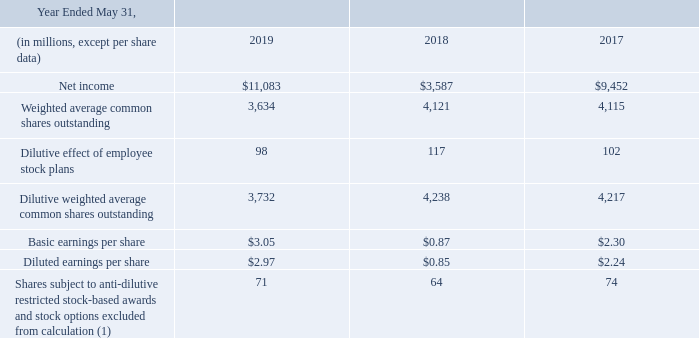Basic earnings per share is computed by dividing net income for the period by the weighted-average number of common shares outstanding during the period. Diluted earnings per share is computed by dividing net income for the period by the weighted-average number of common shares outstanding during the period, plus the dilutive effect of outstanding restricted stock-based awards, stock options, and shares issuable under the employee stock purchase plan using the treasury stock method. The following table sets forth the computation of basic and diluted earnings per share:
(1) These weighted shares relate to anti-dilutive restricted stock-based awards and stock options as calculated using the treasury stock method and contingently issuable shares under PSO and PSU agreements. Such shares could be dilutive in the future. See Note 13 for information regarding the exercise prices of our outstanding, unexercised stock options.
How is basic earnings per share calculated? Basic earnings per share is computed by dividing net income for the period by the weighted-average number of common shares outstanding during the period. Does the table show the calculations for basic or diluted earnings per share, or both? The following table sets forth the computation of basic and diluted earnings per share. Which note should be referred to for information regarding the exercise prices of the company's outstanding, unexercised stock options? See note 13 for information regarding the exercise prices of our outstanding, unexercised stock options. By how much did net income change from 2018 to 2019?
Answer scale should be: million. 11,083-3,587 
Answer: 7496. In 2019, how much more was the basic earnings per share than the diluted earnings per share? 3.05-2.97 
Answer: 0.08. What was the percentage change in dilutive effect of employee stock plans from 2017 to 2018?
Answer scale should be: percent. (117-102)/102 
Answer: 14.71. 